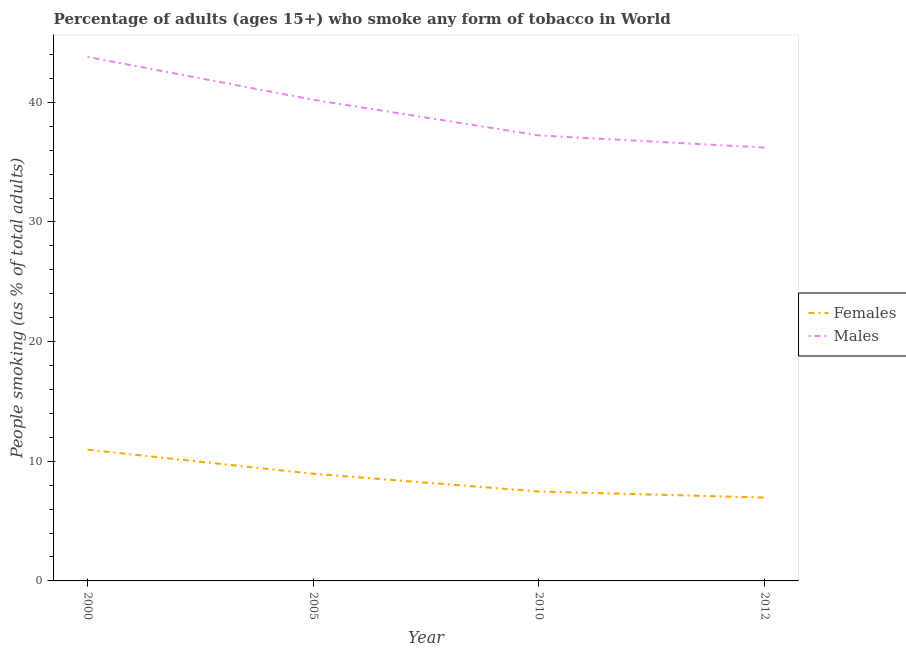How many different coloured lines are there?
Offer a very short reply. 2. Is the number of lines equal to the number of legend labels?
Give a very brief answer. Yes. What is the percentage of males who smoke in 2012?
Your response must be concise. 36.22. Across all years, what is the maximum percentage of males who smoke?
Give a very brief answer. 43.8. Across all years, what is the minimum percentage of males who smoke?
Make the answer very short. 36.22. What is the total percentage of females who smoke in the graph?
Ensure brevity in your answer.  34.36. What is the difference between the percentage of males who smoke in 2010 and that in 2012?
Give a very brief answer. 1.02. What is the difference between the percentage of males who smoke in 2012 and the percentage of females who smoke in 2010?
Provide a succinct answer. 28.74. What is the average percentage of females who smoke per year?
Your response must be concise. 8.59. In the year 2005, what is the difference between the percentage of females who smoke and percentage of males who smoke?
Provide a short and direct response. -31.26. What is the ratio of the percentage of males who smoke in 2010 to that in 2012?
Your response must be concise. 1.03. Is the difference between the percentage of females who smoke in 2000 and 2005 greater than the difference between the percentage of males who smoke in 2000 and 2005?
Offer a terse response. No. What is the difference between the highest and the second highest percentage of males who smoke?
Make the answer very short. 3.58. What is the difference between the highest and the lowest percentage of males who smoke?
Keep it short and to the point. 7.58. Does the percentage of females who smoke monotonically increase over the years?
Ensure brevity in your answer.  No. Is the percentage of males who smoke strictly greater than the percentage of females who smoke over the years?
Provide a short and direct response. Yes. How many lines are there?
Ensure brevity in your answer.  2. How many years are there in the graph?
Provide a short and direct response. 4. What is the difference between two consecutive major ticks on the Y-axis?
Ensure brevity in your answer.  10. Are the values on the major ticks of Y-axis written in scientific E-notation?
Your response must be concise. No. Does the graph contain any zero values?
Make the answer very short. No. Does the graph contain grids?
Make the answer very short. No. Where does the legend appear in the graph?
Your answer should be very brief. Center right. What is the title of the graph?
Keep it short and to the point. Percentage of adults (ages 15+) who smoke any form of tobacco in World. Does "Non-residents" appear as one of the legend labels in the graph?
Offer a terse response. No. What is the label or title of the X-axis?
Ensure brevity in your answer.  Year. What is the label or title of the Y-axis?
Make the answer very short. People smoking (as % of total adults). What is the People smoking (as % of total adults) in Females in 2000?
Your answer should be very brief. 10.97. What is the People smoking (as % of total adults) of Males in 2000?
Make the answer very short. 43.8. What is the People smoking (as % of total adults) in Females in 2005?
Provide a succinct answer. 8.96. What is the People smoking (as % of total adults) of Males in 2005?
Offer a very short reply. 40.22. What is the People smoking (as % of total adults) of Females in 2010?
Provide a succinct answer. 7.47. What is the People smoking (as % of total adults) of Males in 2010?
Your answer should be very brief. 37.23. What is the People smoking (as % of total adults) in Females in 2012?
Your answer should be compact. 6.97. What is the People smoking (as % of total adults) of Males in 2012?
Offer a very short reply. 36.22. Across all years, what is the maximum People smoking (as % of total adults) in Females?
Your answer should be compact. 10.97. Across all years, what is the maximum People smoking (as % of total adults) in Males?
Provide a succinct answer. 43.8. Across all years, what is the minimum People smoking (as % of total adults) of Females?
Your answer should be compact. 6.97. Across all years, what is the minimum People smoking (as % of total adults) of Males?
Your response must be concise. 36.22. What is the total People smoking (as % of total adults) in Females in the graph?
Provide a succinct answer. 34.36. What is the total People smoking (as % of total adults) of Males in the graph?
Offer a very short reply. 157.46. What is the difference between the People smoking (as % of total adults) of Females in 2000 and that in 2005?
Offer a terse response. 2.01. What is the difference between the People smoking (as % of total adults) in Males in 2000 and that in 2005?
Ensure brevity in your answer.  3.58. What is the difference between the People smoking (as % of total adults) in Females in 2000 and that in 2010?
Your response must be concise. 3.49. What is the difference between the People smoking (as % of total adults) of Males in 2000 and that in 2010?
Give a very brief answer. 6.56. What is the difference between the People smoking (as % of total adults) of Females in 2000 and that in 2012?
Give a very brief answer. 4. What is the difference between the People smoking (as % of total adults) in Males in 2000 and that in 2012?
Ensure brevity in your answer.  7.58. What is the difference between the People smoking (as % of total adults) of Females in 2005 and that in 2010?
Keep it short and to the point. 1.48. What is the difference between the People smoking (as % of total adults) of Males in 2005 and that in 2010?
Give a very brief answer. 2.98. What is the difference between the People smoking (as % of total adults) of Females in 2005 and that in 2012?
Your answer should be very brief. 1.99. What is the difference between the People smoking (as % of total adults) in Males in 2005 and that in 2012?
Offer a very short reply. 4. What is the difference between the People smoking (as % of total adults) in Females in 2010 and that in 2012?
Offer a terse response. 0.51. What is the difference between the People smoking (as % of total adults) of Males in 2010 and that in 2012?
Your answer should be very brief. 1.02. What is the difference between the People smoking (as % of total adults) of Females in 2000 and the People smoking (as % of total adults) of Males in 2005?
Provide a succinct answer. -29.25. What is the difference between the People smoking (as % of total adults) of Females in 2000 and the People smoking (as % of total adults) of Males in 2010?
Ensure brevity in your answer.  -26.27. What is the difference between the People smoking (as % of total adults) in Females in 2000 and the People smoking (as % of total adults) in Males in 2012?
Ensure brevity in your answer.  -25.25. What is the difference between the People smoking (as % of total adults) of Females in 2005 and the People smoking (as % of total adults) of Males in 2010?
Give a very brief answer. -28.28. What is the difference between the People smoking (as % of total adults) in Females in 2005 and the People smoking (as % of total adults) in Males in 2012?
Offer a terse response. -27.26. What is the difference between the People smoking (as % of total adults) of Females in 2010 and the People smoking (as % of total adults) of Males in 2012?
Your answer should be compact. -28.74. What is the average People smoking (as % of total adults) of Females per year?
Give a very brief answer. 8.59. What is the average People smoking (as % of total adults) of Males per year?
Your response must be concise. 39.37. In the year 2000, what is the difference between the People smoking (as % of total adults) of Females and People smoking (as % of total adults) of Males?
Your answer should be very brief. -32.83. In the year 2005, what is the difference between the People smoking (as % of total adults) of Females and People smoking (as % of total adults) of Males?
Make the answer very short. -31.26. In the year 2010, what is the difference between the People smoking (as % of total adults) of Females and People smoking (as % of total adults) of Males?
Your answer should be very brief. -29.76. In the year 2012, what is the difference between the People smoking (as % of total adults) of Females and People smoking (as % of total adults) of Males?
Your answer should be very brief. -29.25. What is the ratio of the People smoking (as % of total adults) in Females in 2000 to that in 2005?
Provide a succinct answer. 1.22. What is the ratio of the People smoking (as % of total adults) of Males in 2000 to that in 2005?
Your answer should be compact. 1.09. What is the ratio of the People smoking (as % of total adults) in Females in 2000 to that in 2010?
Ensure brevity in your answer.  1.47. What is the ratio of the People smoking (as % of total adults) of Males in 2000 to that in 2010?
Provide a succinct answer. 1.18. What is the ratio of the People smoking (as % of total adults) of Females in 2000 to that in 2012?
Ensure brevity in your answer.  1.57. What is the ratio of the People smoking (as % of total adults) of Males in 2000 to that in 2012?
Provide a succinct answer. 1.21. What is the ratio of the People smoking (as % of total adults) in Females in 2005 to that in 2010?
Provide a short and direct response. 1.2. What is the ratio of the People smoking (as % of total adults) of Males in 2005 to that in 2010?
Provide a succinct answer. 1.08. What is the ratio of the People smoking (as % of total adults) in Females in 2005 to that in 2012?
Your answer should be very brief. 1.29. What is the ratio of the People smoking (as % of total adults) of Males in 2005 to that in 2012?
Make the answer very short. 1.11. What is the ratio of the People smoking (as % of total adults) in Females in 2010 to that in 2012?
Provide a short and direct response. 1.07. What is the ratio of the People smoking (as % of total adults) in Males in 2010 to that in 2012?
Offer a very short reply. 1.03. What is the difference between the highest and the second highest People smoking (as % of total adults) of Females?
Make the answer very short. 2.01. What is the difference between the highest and the second highest People smoking (as % of total adults) in Males?
Your answer should be very brief. 3.58. What is the difference between the highest and the lowest People smoking (as % of total adults) in Females?
Your answer should be compact. 4. What is the difference between the highest and the lowest People smoking (as % of total adults) in Males?
Your answer should be very brief. 7.58. 